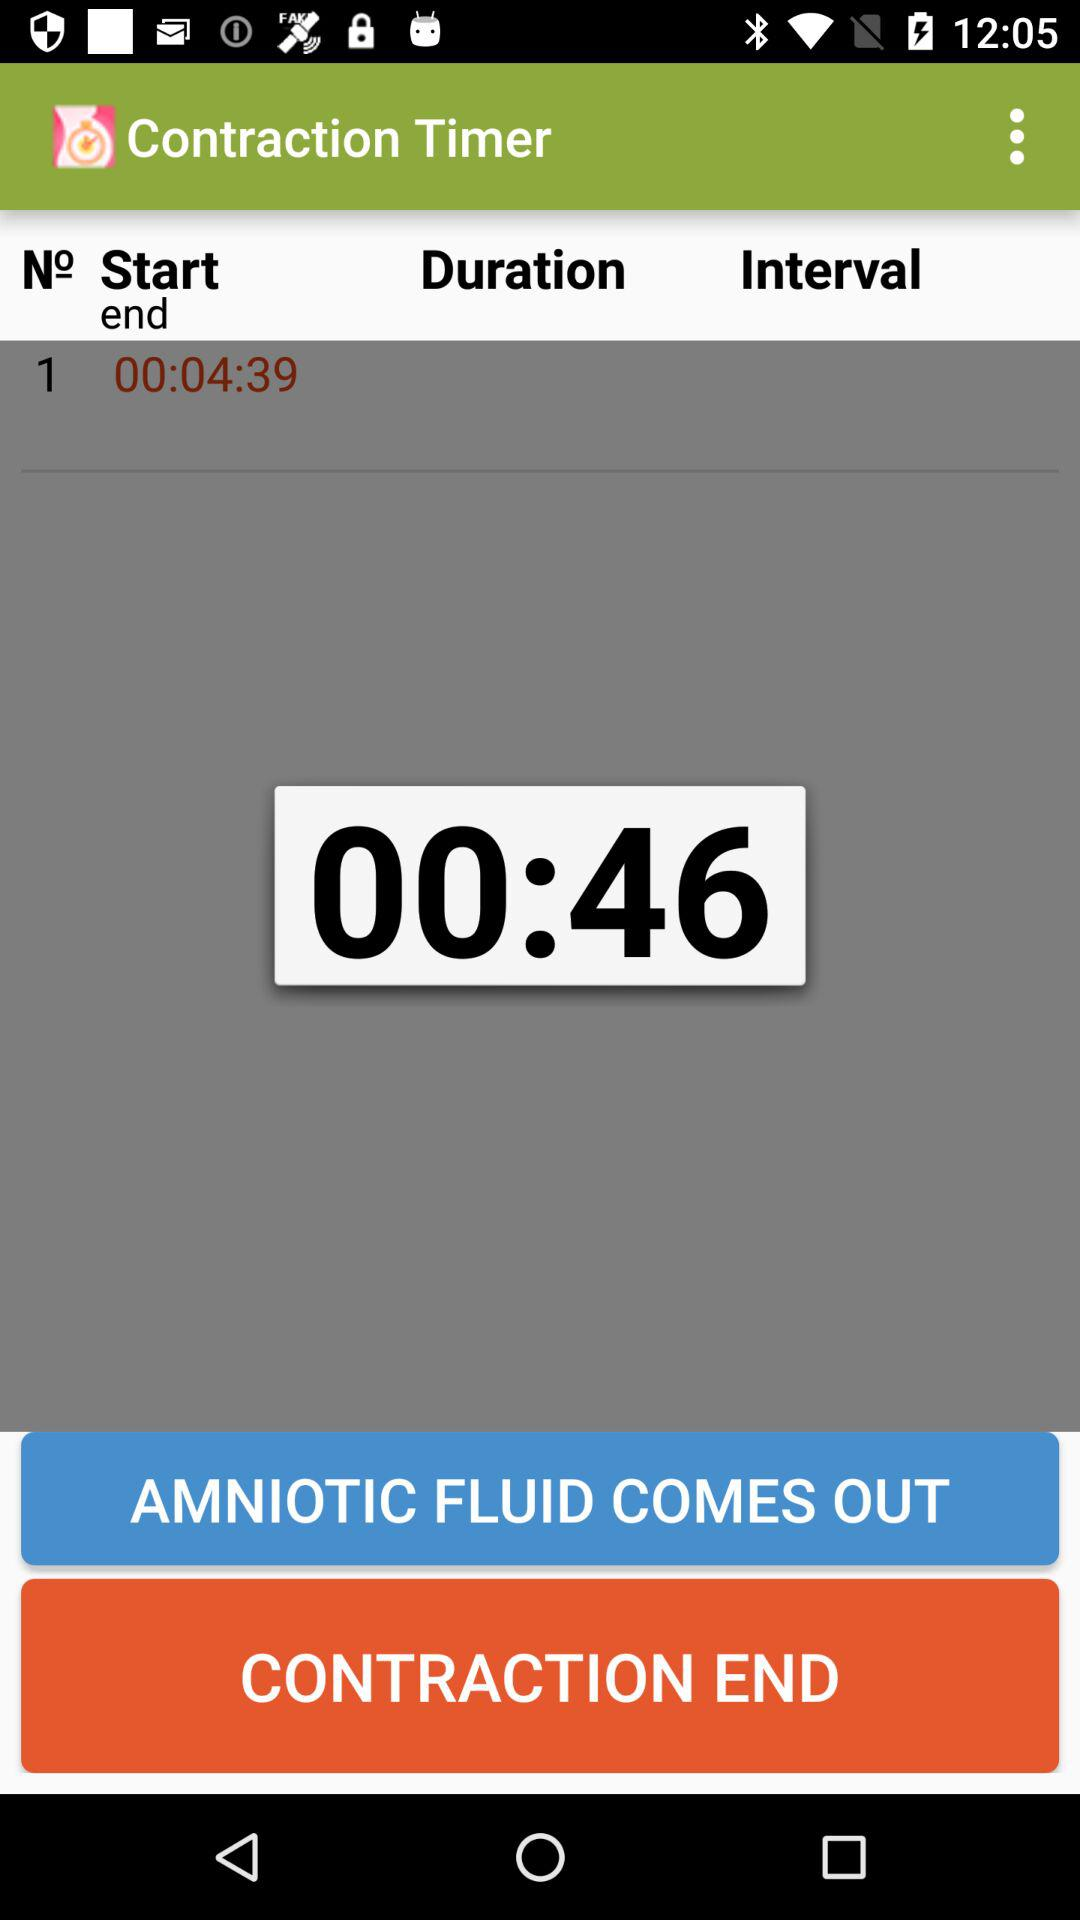What is the timer shown on the display? The timer is "00:46". 